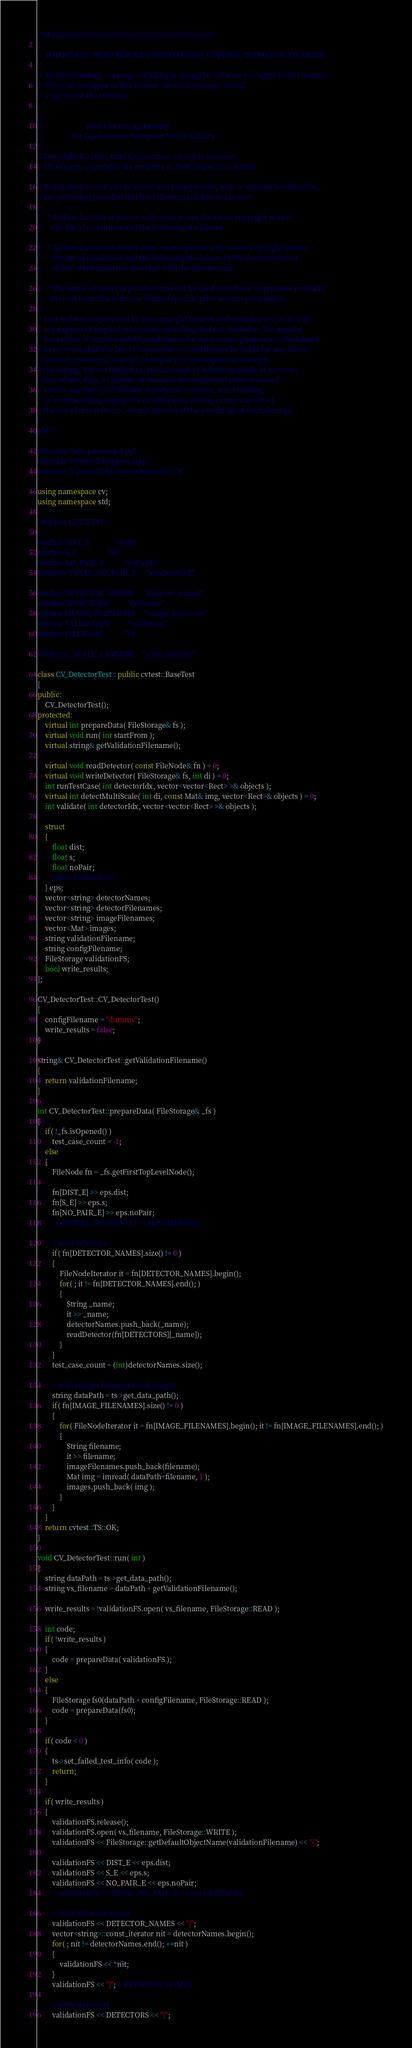<code> <loc_0><loc_0><loc_500><loc_500><_C++_>/*M///////////////////////////////////////////////////////////////////////////////////////
//
//  IMPORTANT: READ BEFORE DOWNLOADING, COPYING, INSTALLING OR USING.
//
//  By downloading, copying, installing or using the software you agree to this license.
//  If you do not agree to this license, do not download, install,
//  copy or use the software.
//
//
//                        Intel License Agreement
//                For Open Source Computer Vision Library
//
// Copyright (C) 2000, Intel Corporation, all rights reserved.
// Third party copyrights are property of their respective owners.
//
// Redistribution and use in source and binary forms, with or without modification,
// are permitted provided that the following conditions are met:
//
//   * Redistribution's of source code must retain the above copyright notice,
//     this list of conditions and the following disclaimer.
//
//   * Redistribution's in binary form must reproduce the above copyright notice,
//     this list of conditions and the following disclaimer in the documentation
//     and/or other materials provided with the distribution.
//
//   * The name of Intel Corporation may not be used to endorse or promote products
//     derived from this software without specific prior written permission.
//
// This software is provided by the copyright holders and contributors "as is" and
// any express or implied warranties, including, but not limited to, the implied
// warranties of merchantability and fitness for a particular purpose are disclaimed.
// In no event shall the Intel Corporation or contributors be liable for any direct,
// indirect, incidental, special, exemplary, or consequential damages
// (including, but not limited to, procurement of substitute goods or services;
// loss of use, data, or profits; or business interruption) however caused
// and on any theory of liability, whether in contract, strict liability,
// or tort (including negligence or otherwise) arising in any way out of
// the use of this software, even if advised of the possibility of such damage.
//
//M*/

#include "test_precomp.hpp"
#include "opencv2/imgproc.hpp"
#include "opencv2/objdetect/objdetect_c.h"

using namespace cv;
using namespace std;

//#define GET_STAT

#define DIST_E              "distE"
#define S_E                 "sE"
#define NO_PAIR_E           "noPairE"
//#define TOTAL_NO_PAIR_E     "totalNoPairE"

#define DETECTOR_NAMES      "detector_names"
#define DETECTORS           "detectors"
#define IMAGE_FILENAMES     "image_filenames"
#define VALIDATION          "validation"
#define FILENAME            "fn"

#define C_SCALE_CASCADE     "scale_cascade"

class CV_DetectorTest : public cvtest::BaseTest
{
public:
    CV_DetectorTest();
protected:
    virtual int prepareData( FileStorage& fs );
    virtual void run( int startFrom );
    virtual string& getValidationFilename();

    virtual void readDetector( const FileNode& fn ) = 0;
    virtual void writeDetector( FileStorage& fs, int di ) = 0;
    int runTestCase( int detectorIdx, vector<vector<Rect> >& objects );
    virtual int detectMultiScale( int di, const Mat& img, vector<Rect>& objects ) = 0;
    int validate( int detectorIdx, vector<vector<Rect> >& objects );

    struct
    {
        float dist;
        float s;
        float noPair;
        //float totalNoPair;
    } eps;
    vector<string> detectorNames;
    vector<string> detectorFilenames;
    vector<string> imageFilenames;
    vector<Mat> images;
    string validationFilename;
    string configFilename;
    FileStorage validationFS;
    bool write_results;
};

CV_DetectorTest::CV_DetectorTest()
{
    configFilename = "dummy";
    write_results = false;
}

string& CV_DetectorTest::getValidationFilename()
{
    return validationFilename;
}

int CV_DetectorTest::prepareData( FileStorage& _fs )
{
    if( !_fs.isOpened() )
        test_case_count = -1;
    else
    {
        FileNode fn = _fs.getFirstTopLevelNode();

        fn[DIST_E] >> eps.dist;
        fn[S_E] >> eps.s;
        fn[NO_PAIR_E] >> eps.noPair;
//        fn[TOTAL_NO_PAIR_E] >> eps.totalNoPair;

        // read detectors
        if( fn[DETECTOR_NAMES].size() != 0 )
        {
            FileNodeIterator it = fn[DETECTOR_NAMES].begin();
            for( ; it != fn[DETECTOR_NAMES].end(); )
            {
                String _name;
                it >> _name;
                detectorNames.push_back(_name);
                readDetector(fn[DETECTORS][_name]);
            }
        }
        test_case_count = (int)detectorNames.size();

        // read images filenames and images
        string dataPath = ts->get_data_path();
        if( fn[IMAGE_FILENAMES].size() != 0 )
        {
            for( FileNodeIterator it = fn[IMAGE_FILENAMES].begin(); it != fn[IMAGE_FILENAMES].end(); )
            {
                String filename;
                it >> filename;
                imageFilenames.push_back(filename);
                Mat img = imread( dataPath+filename, 1 );
                images.push_back( img );
            }
        }
    }
    return cvtest::TS::OK;
}

void CV_DetectorTest::run( int )
{
    string dataPath = ts->get_data_path();
    string vs_filename = dataPath + getValidationFilename();

    write_results = !validationFS.open( vs_filename, FileStorage::READ );

    int code;
    if( !write_results )
    {
        code = prepareData( validationFS );
    }
    else
    {
        FileStorage fs0(dataPath + configFilename, FileStorage::READ );
        code = prepareData(fs0);
    }

    if( code < 0 )
    {
        ts->set_failed_test_info( code );
        return;
    }

    if( write_results )
    {
        validationFS.release();
        validationFS.open( vs_filename, FileStorage::WRITE );
        validationFS << FileStorage::getDefaultObjectName(validationFilename) << "{";

        validationFS << DIST_E << eps.dist;
        validationFS << S_E << eps.s;
        validationFS << NO_PAIR_E << eps.noPair;
    //    validationFS << TOTAL_NO_PAIR_E << eps.totalNoPair;

        // write detector names
        validationFS << DETECTOR_NAMES << "[";
        vector<string>::const_iterator nit = detectorNames.begin();
        for( ; nit != detectorNames.end(); ++nit )
        {
            validationFS << *nit;
        }
        validationFS << "]"; // DETECTOR_NAMES

        // write detectors
        validationFS << DETECTORS << "{";</code> 